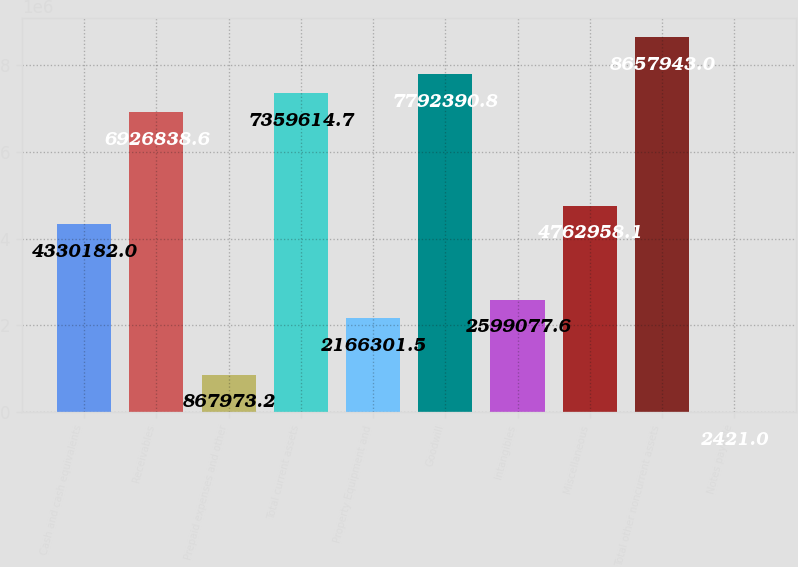Convert chart to OTSL. <chart><loc_0><loc_0><loc_500><loc_500><bar_chart><fcel>Cash and cash equivalents<fcel>Receivables<fcel>Prepaid expenses and other<fcel>Total current assets<fcel>Property Equipment and<fcel>Goodwill<fcel>Intangibles<fcel>Miscellaneous<fcel>Total other noncurrent assets<fcel>Notes payable<nl><fcel>4.33018e+06<fcel>6.92684e+06<fcel>867973<fcel>7.35961e+06<fcel>2.1663e+06<fcel>7.79239e+06<fcel>2.59908e+06<fcel>4.76296e+06<fcel>8.65794e+06<fcel>2421<nl></chart> 